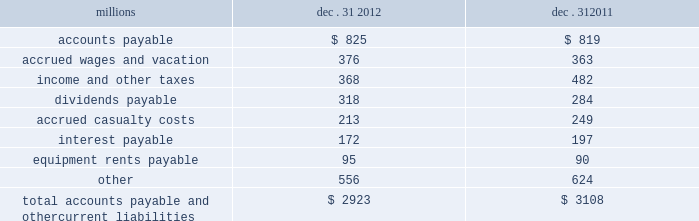The analysis of our depreciation studies .
Changes in the estimated service lives of our assets and their related depreciation rates are implemented prospectively .
Under group depreciation , the historical cost ( net of salvage ) of depreciable property that is retired or replaced in the ordinary course of business is charged to accumulated depreciation and no gain or loss is recognized .
The historical cost of certain track assets is estimated using ( i ) inflation indices published by the bureau of labor statistics and ( ii ) the estimated useful lives of the assets as determined by our depreciation studies .
The indices were selected because they closely correlate with the major costs of the properties comprising the applicable track asset classes .
Because of the number of estimates inherent in the depreciation and retirement processes and because it is impossible to precisely estimate each of these variables until a group of property is completely retired , we continually monitor the estimated service lives of our assets and the accumulated depreciation associated with each asset class to ensure our depreciation rates are appropriate .
In addition , we determine if the recorded amount of accumulated depreciation is deficient ( or in excess ) of the amount indicated by our depreciation studies .
Any deficiency ( or excess ) is amortized as a component of depreciation expense over the remaining service lives of the applicable classes of assets .
For retirements of depreciable railroad properties that do not occur in the normal course of business , a gain or loss may be recognized if the retirement meets each of the following three conditions : ( i ) is unusual , ( ii ) is material in amount , and ( iii ) varies significantly from the retirement profile identified through our depreciation studies .
A gain or loss is recognized in other income when we sell land or dispose of assets that are not part of our railroad operations .
When we purchase an asset , we capitalize all costs necessary to make the asset ready for its intended use .
However , many of our assets are self-constructed .
A large portion of our capital expenditures is for replacement of existing track assets and other road properties , which is typically performed by our employees , and for track line expansion and other capacity projects .
Costs that are directly attributable to capital projects ( including overhead costs ) are capitalized .
Direct costs that are capitalized as part of self- constructed assets include material , labor , and work equipment .
Indirect costs are capitalized if they clearly relate to the construction of the asset .
General and administrative expenditures are expensed as incurred .
Normal repairs and maintenance , including rail grinding , are also expensed as incurred , while costs incurred that extend the useful life of an asset , improve the safety of our operations or improve operating efficiency are capitalized .
These costs are allocated using appropriate statistical bases .
Total expense for repairs and maintenance incurred was $ 2.1 billion for 2012 , $ 2.2 billion for 2011 , and $ 2.0 billion for 2010 .
Assets held under capital leases are recorded at the lower of the net present value of the minimum lease payments or the fair value of the leased asset at the inception of the lease .
Amortization expense is computed using the straight-line method over the shorter of the estimated useful lives of the assets or the period of the related lease .
12 .
Accounts payable and other current liabilities dec .
31 , dec .
31 , millions 2012 2011 .

What was the percentage change in accrued wages and vacation from 2011 to 2012? 
Computations: ((376 - 363) / 363)
Answer: 0.03581. 